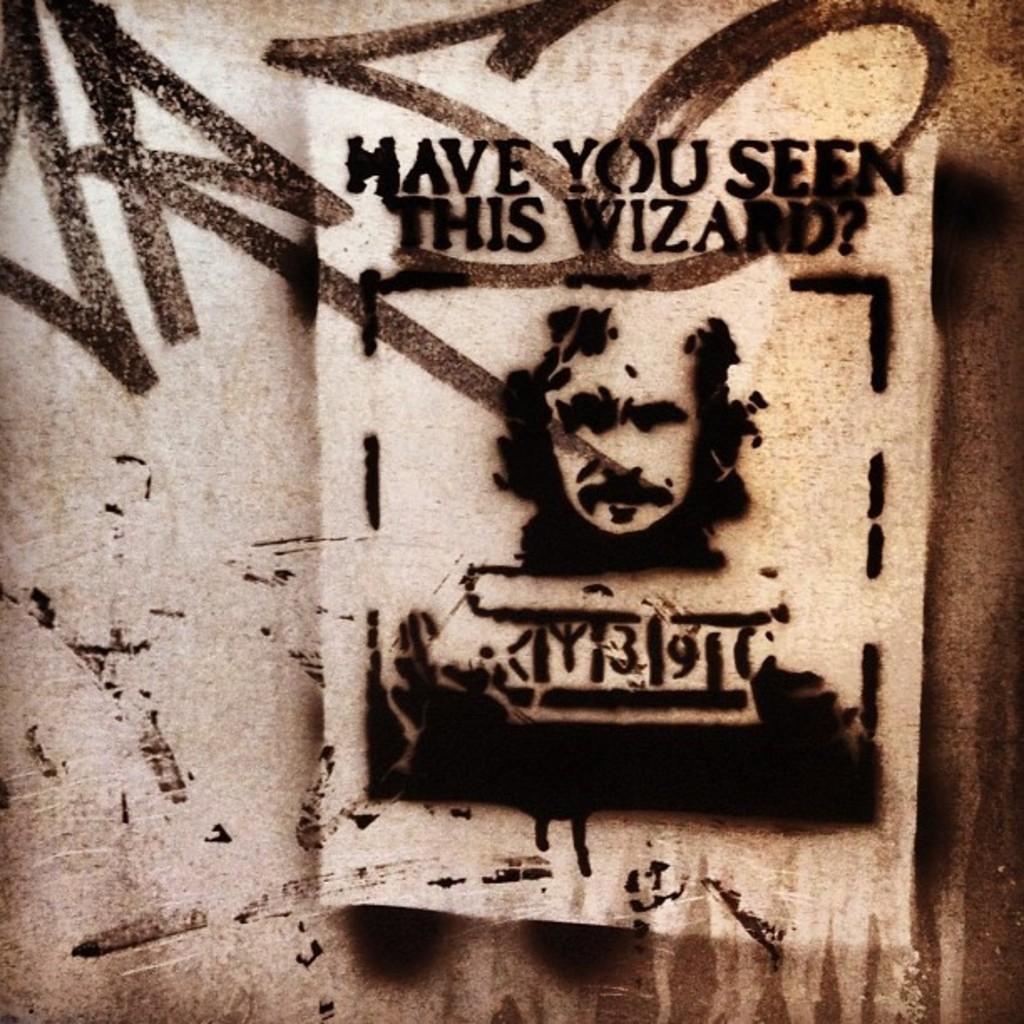In one or two sentences, can you explain what this image depicts? In this image there is a poster of a person on the wall. 